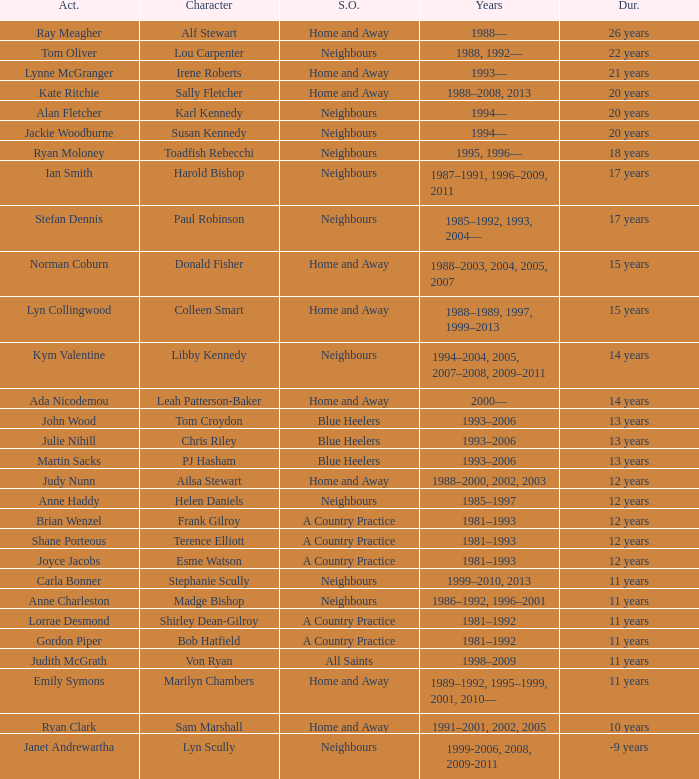Which actor played Harold Bishop for 17 years? Ian Smith. 